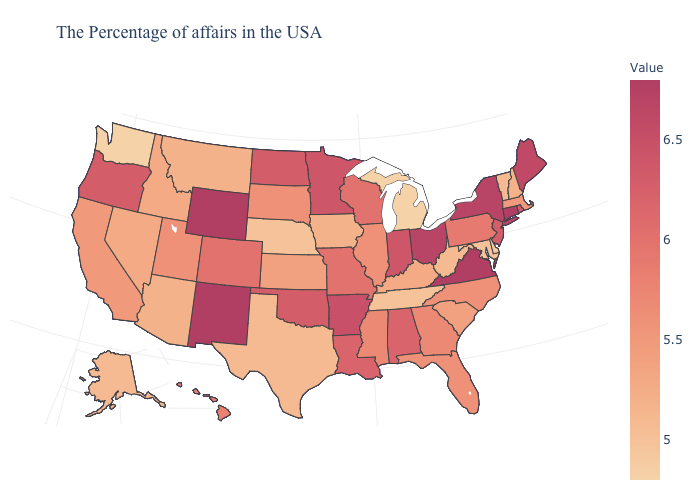Among the states that border West Virginia , does Maryland have the lowest value?
Write a very short answer. Yes. Which states have the lowest value in the Northeast?
Concise answer only. Vermont. Which states have the lowest value in the MidWest?
Concise answer only. Michigan. Does the map have missing data?
Answer briefly. No. Among the states that border Ohio , does Indiana have the highest value?
Answer briefly. Yes. Is the legend a continuous bar?
Write a very short answer. Yes. Which states have the lowest value in the USA?
Answer briefly. Michigan, Washington. 